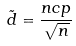<formula> <loc_0><loc_0><loc_500><loc_500>\tilde { d } = \frac { n c p } { \sqrt { n } }</formula> 